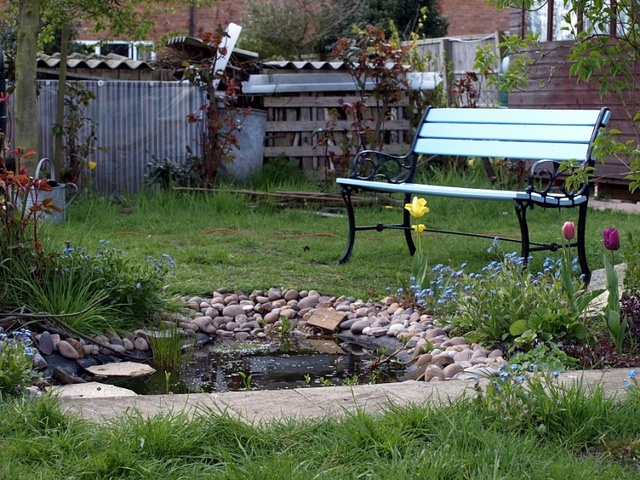Describe the objects in this image and their specific colors. I can see a bench in olive, lightblue, black, and darkgreen tones in this image. 